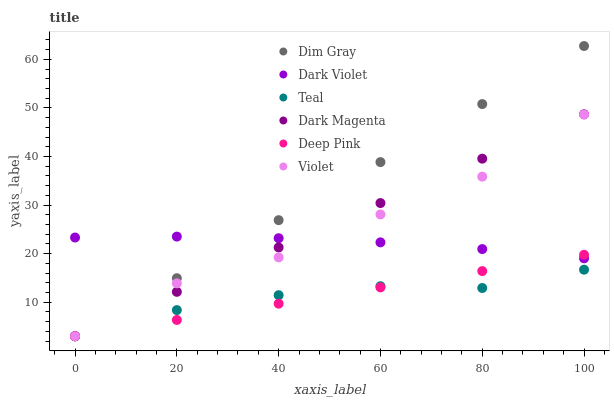Does Teal have the minimum area under the curve?
Answer yes or no. Yes. Does Dim Gray have the maximum area under the curve?
Answer yes or no. Yes. Does Dark Magenta have the minimum area under the curve?
Answer yes or no. No. Does Dark Magenta have the maximum area under the curve?
Answer yes or no. No. Is Deep Pink the smoothest?
Answer yes or no. Yes. Is Violet the roughest?
Answer yes or no. Yes. Is Dark Violet the smoothest?
Answer yes or no. No. Is Dark Violet the roughest?
Answer yes or no. No. Does Deep Pink have the lowest value?
Answer yes or no. Yes. Does Dark Violet have the lowest value?
Answer yes or no. No. Does Dim Gray have the highest value?
Answer yes or no. Yes. Does Dark Magenta have the highest value?
Answer yes or no. No. Is Teal less than Dark Violet?
Answer yes or no. Yes. Is Dark Violet greater than Teal?
Answer yes or no. Yes. Does Teal intersect Deep Pink?
Answer yes or no. Yes. Is Teal less than Deep Pink?
Answer yes or no. No. Is Teal greater than Deep Pink?
Answer yes or no. No. Does Teal intersect Dark Violet?
Answer yes or no. No. 